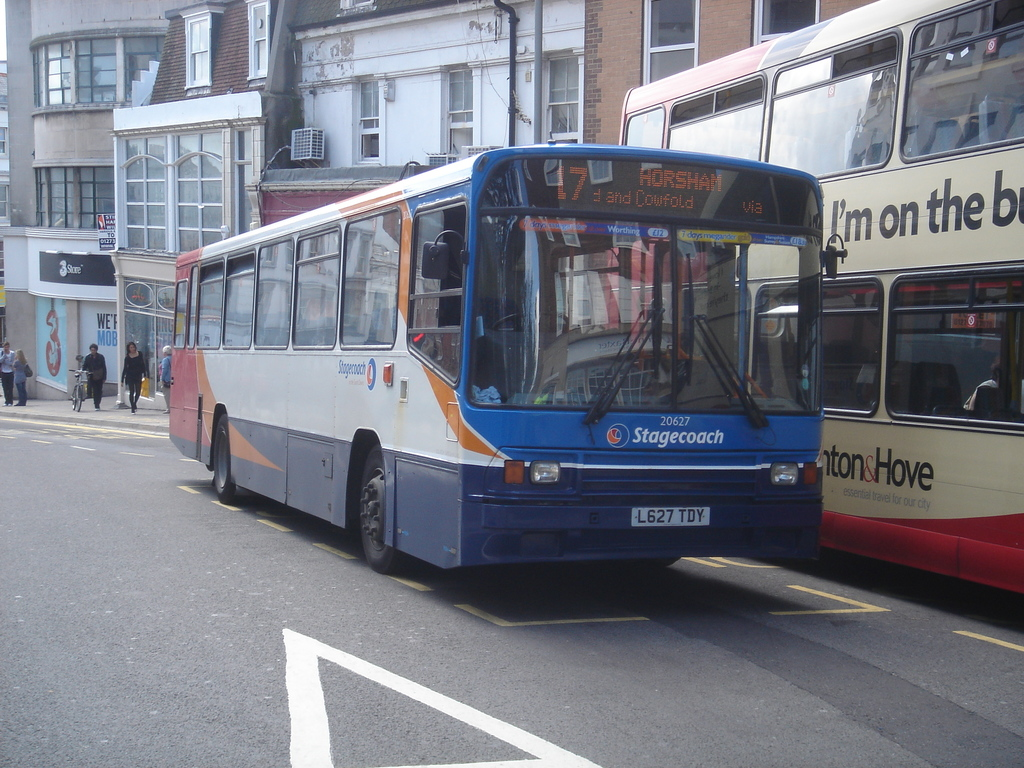Provide a one-sentence caption for the provided image. Bus number 17, adorned in vibrant blue and orange, maneuvers through the city streets, passing a double-decker bus, as it routes towards Horsham, indicating a bustling urban transit scene. 